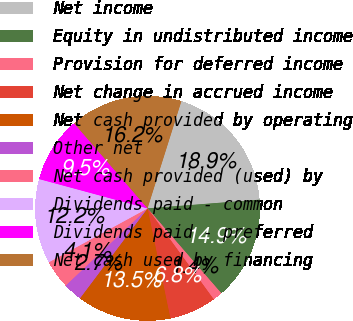Convert chart to OTSL. <chart><loc_0><loc_0><loc_500><loc_500><pie_chart><fcel>Net income<fcel>Equity in undistributed income<fcel>Provision for deferred income<fcel>Net change in accrued income<fcel>Net cash provided by operating<fcel>Other net<fcel>Net cash provided (used) by<fcel>Dividends paid - common<fcel>Dividends paid - preferred<fcel>Net cash used by financing<nl><fcel>18.9%<fcel>14.85%<fcel>1.37%<fcel>6.76%<fcel>13.51%<fcel>2.72%<fcel>4.07%<fcel>12.16%<fcel>9.46%<fcel>16.2%<nl></chart> 